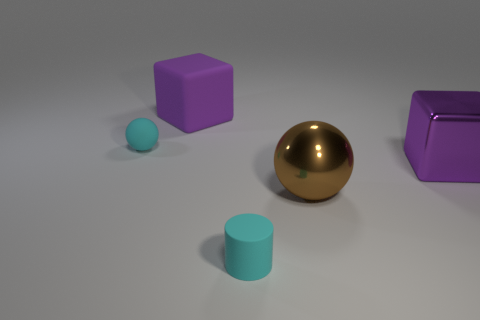What material is the cylinder?
Ensure brevity in your answer.  Rubber. Do the small ball and the cylinder have the same color?
Ensure brevity in your answer.  Yes. Are there fewer small spheres that are to the left of the cyan sphere than big green rubber objects?
Provide a short and direct response. No. There is a large cube behind the big shiny block; what color is it?
Your answer should be very brief. Purple. The brown metal object is what shape?
Give a very brief answer. Sphere. There is a block that is in front of the rubber ball on the left side of the cyan rubber cylinder; are there any big things that are behind it?
Offer a very short reply. Yes. What is the color of the small rubber ball that is behind the small rubber thing that is in front of the rubber ball behind the purple metal cube?
Keep it short and to the point. Cyan. There is another purple object that is the same shape as the large rubber thing; what is its material?
Give a very brief answer. Metal. There is a purple block behind the large purple object in front of the tiny ball; how big is it?
Provide a succinct answer. Large. What is the material of the small cyan object that is in front of the cyan rubber sphere?
Your answer should be very brief. Rubber. 